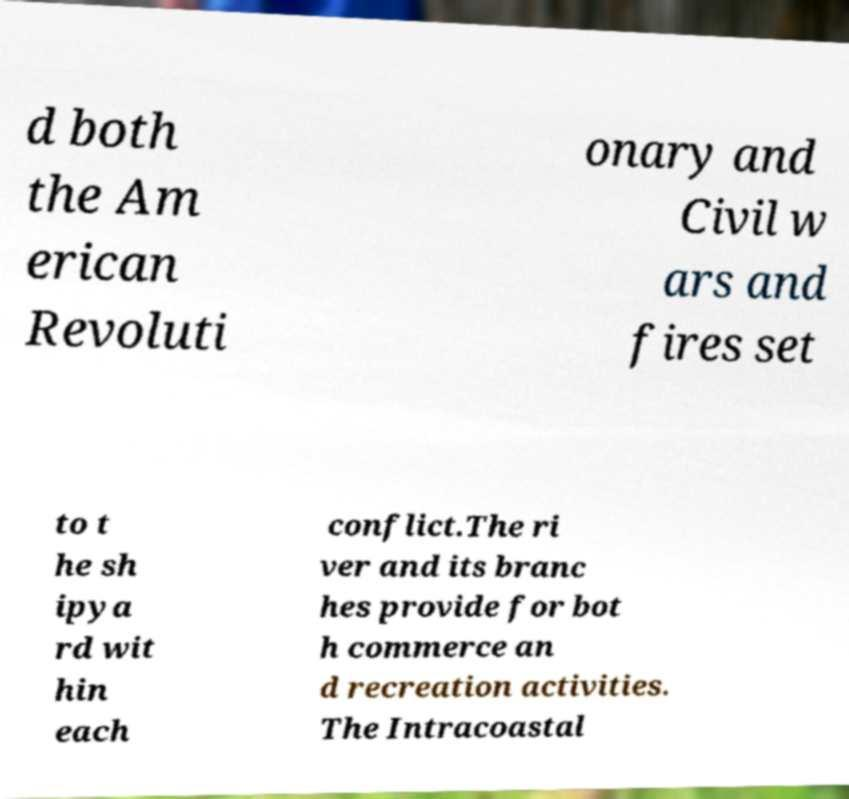Could you assist in decoding the text presented in this image and type it out clearly? d both the Am erican Revoluti onary and Civil w ars and fires set to t he sh ipya rd wit hin each conflict.The ri ver and its branc hes provide for bot h commerce an d recreation activities. The Intracoastal 